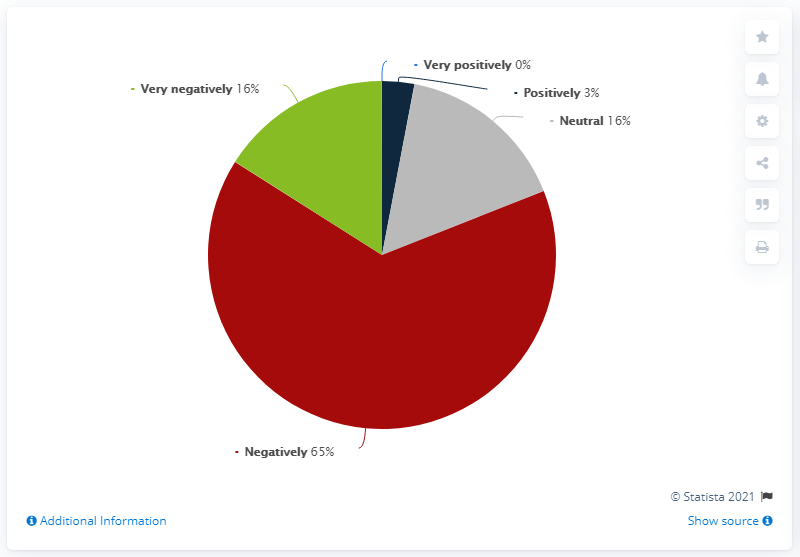Draw attention to some important aspects in this diagram. The ratio of the green segment to the second largest segment is 1 to 1. The coronavirus outbreak is expected to have a significant negative impact on our business, potentially amounting to X% of our revenue. 